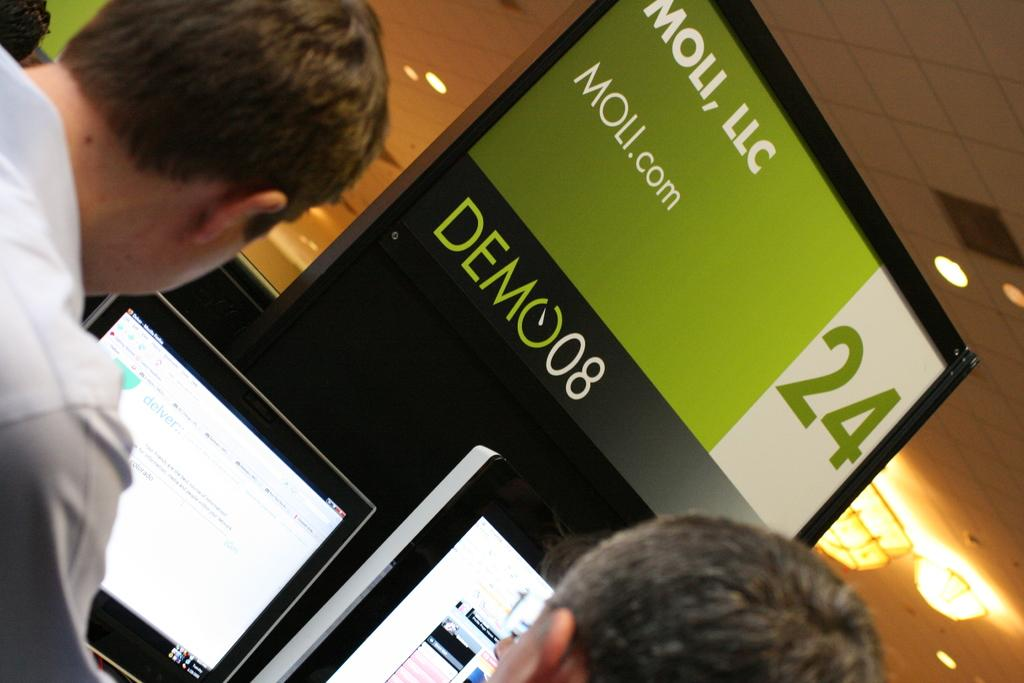Who or what can be seen in the image? There are people in the image. What are the people interacting with in the image? There are computers in front of the people. Is there any text or information displayed in the image? Yes, there is a board with writing in the image. What type of lighting is present in the image? There are lights on the ceiling. What type of fiction is being read by the people in the image? There is no indication in the image that the people are reading fiction, as the focus is on the computers and board with writing. 